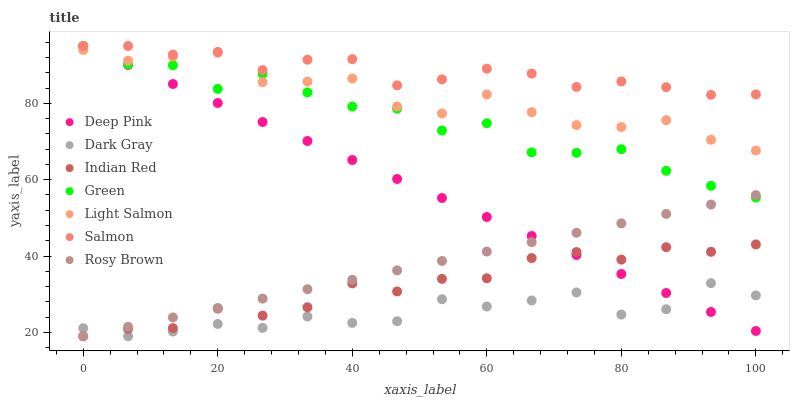Does Dark Gray have the minimum area under the curve?
Answer yes or no. Yes. Does Salmon have the maximum area under the curve?
Answer yes or no. Yes. Does Deep Pink have the minimum area under the curve?
Answer yes or no. No. Does Deep Pink have the maximum area under the curve?
Answer yes or no. No. Is Deep Pink the smoothest?
Answer yes or no. Yes. Is Green the roughest?
Answer yes or no. Yes. Is Rosy Brown the smoothest?
Answer yes or no. No. Is Rosy Brown the roughest?
Answer yes or no. No. Does Rosy Brown have the lowest value?
Answer yes or no. Yes. Does Deep Pink have the lowest value?
Answer yes or no. No. Does Green have the highest value?
Answer yes or no. Yes. Does Rosy Brown have the highest value?
Answer yes or no. No. Is Dark Gray less than Light Salmon?
Answer yes or no. Yes. Is Green greater than Dark Gray?
Answer yes or no. Yes. Does Rosy Brown intersect Dark Gray?
Answer yes or no. Yes. Is Rosy Brown less than Dark Gray?
Answer yes or no. No. Is Rosy Brown greater than Dark Gray?
Answer yes or no. No. Does Dark Gray intersect Light Salmon?
Answer yes or no. No. 